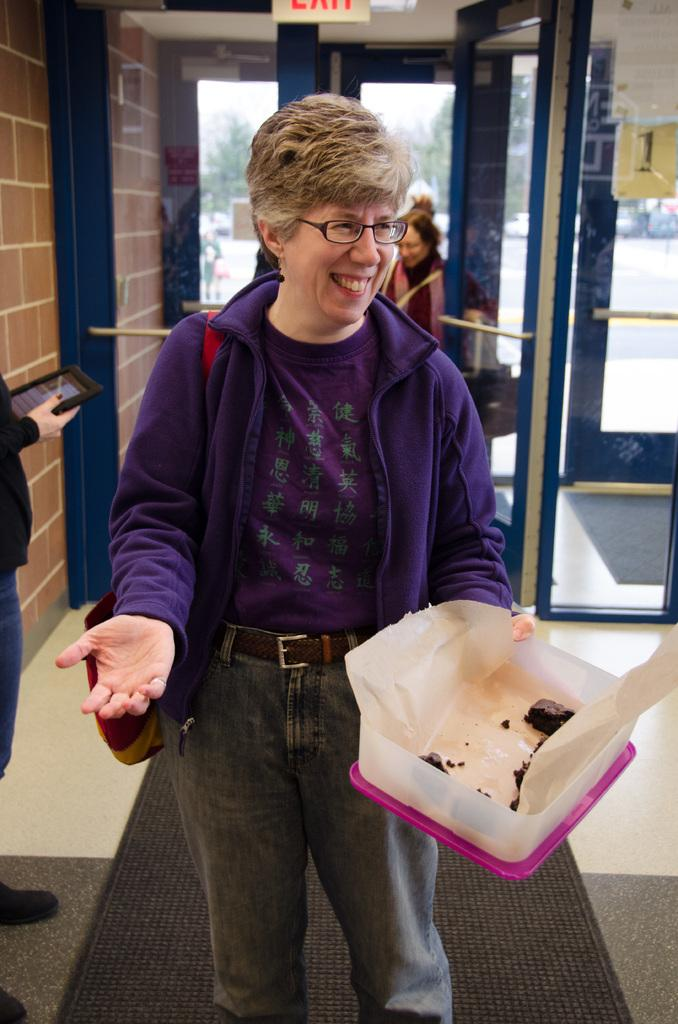Who is the main subject in the image? There is an old woman in the image. What is the old woman wearing? The old woman is wearing a purple dress. What is the old woman holding in the image? The old woman is holding a box. Can you describe the people visible behind the old woman? There are people visible behind the old woman, but their specific features cannot be determined from the image. What architectural feature can be seen in the image? There is a glass door in the image. What is located on the left side of the image? There is a wall on the left side of the image. What type of stamp can be seen on the old woman's forehead in the image? There is no stamp visible on the old woman's forehead in the image. 